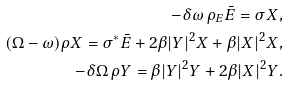<formula> <loc_0><loc_0><loc_500><loc_500>- \delta \omega \, \rho _ { E } \bar { E } = \sigma X , \\ ( \Omega - \omega ) \rho X = \sigma ^ { * } \bar { E } + 2 \beta | Y | ^ { 2 } X + \beta | X | ^ { 2 } X , \\ - \delta \Omega \, \rho Y = \beta | Y | ^ { 2 } Y + 2 \beta | X | ^ { 2 } Y .</formula> 